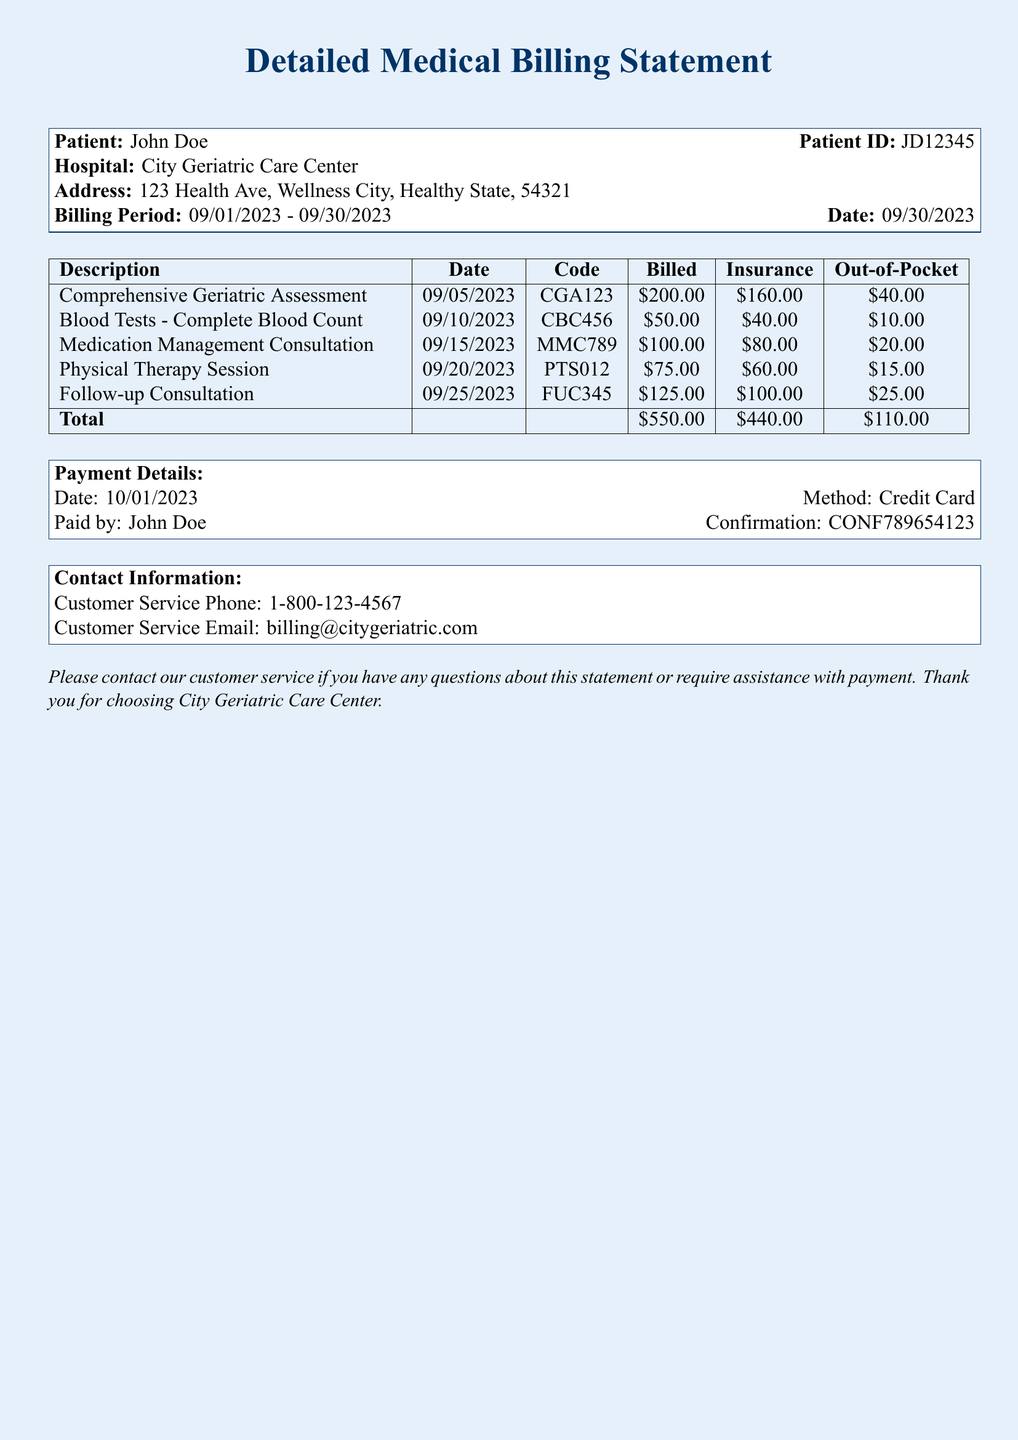What is the patient ID? The patient ID is displayed in the document under the patient information section.
Answer: JD12345 What is the billing period? The billing period indicates the dates of services billed, found in the document.
Answer: 09/01/2023 - 09/30/2023 How much was billed for the Comprehensive Geriatric Assessment? The billed amount for each service is listed in the table.
Answer: $200.00 What was the insurance contribution for the Blood Tests? The insurance contribution amounts are detailed in the table for each service.
Answer: $40.00 What is the total out-of-pocket expense? The total out-of-pocket expense is calculated at the bottom of the table.
Answer: $110.00 How many services are listed in the document? The number of services can be counted from the items in the table.
Answer: 5 What method of payment was used? The payment method is noted in the payment details section of the document.
Answer: Credit Card What is the contact phone number for customer service? The contact information is provided at the bottom of the document.
Answer: 1-800-123-4567 What was the payment confirmation number? The confirmation number is provided in the payment details section.
Answer: CONF789654123 